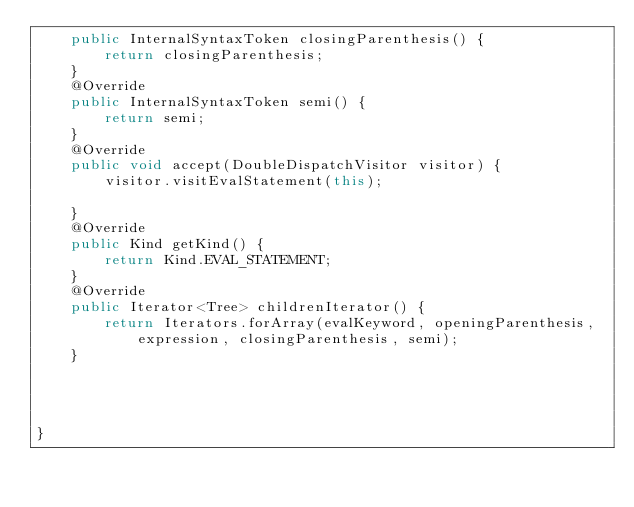Convert code to text. <code><loc_0><loc_0><loc_500><loc_500><_Java_>	public InternalSyntaxToken closingParenthesis() {
		return closingParenthesis;
	}
	@Override
	public InternalSyntaxToken semi() {
		return semi;
	}
	@Override
	public void accept(DoubleDispatchVisitor visitor) {
		visitor.visitEvalStatement(this);
		
	}
	@Override
	public Kind getKind() {
		return Kind.EVAL_STATEMENT;
	}
	@Override
	public Iterator<Tree> childrenIterator() {
		return Iterators.forArray(evalKeyword, openingParenthesis, expression, closingParenthesis, semi);
	}
	
	
	
	
}
</code> 